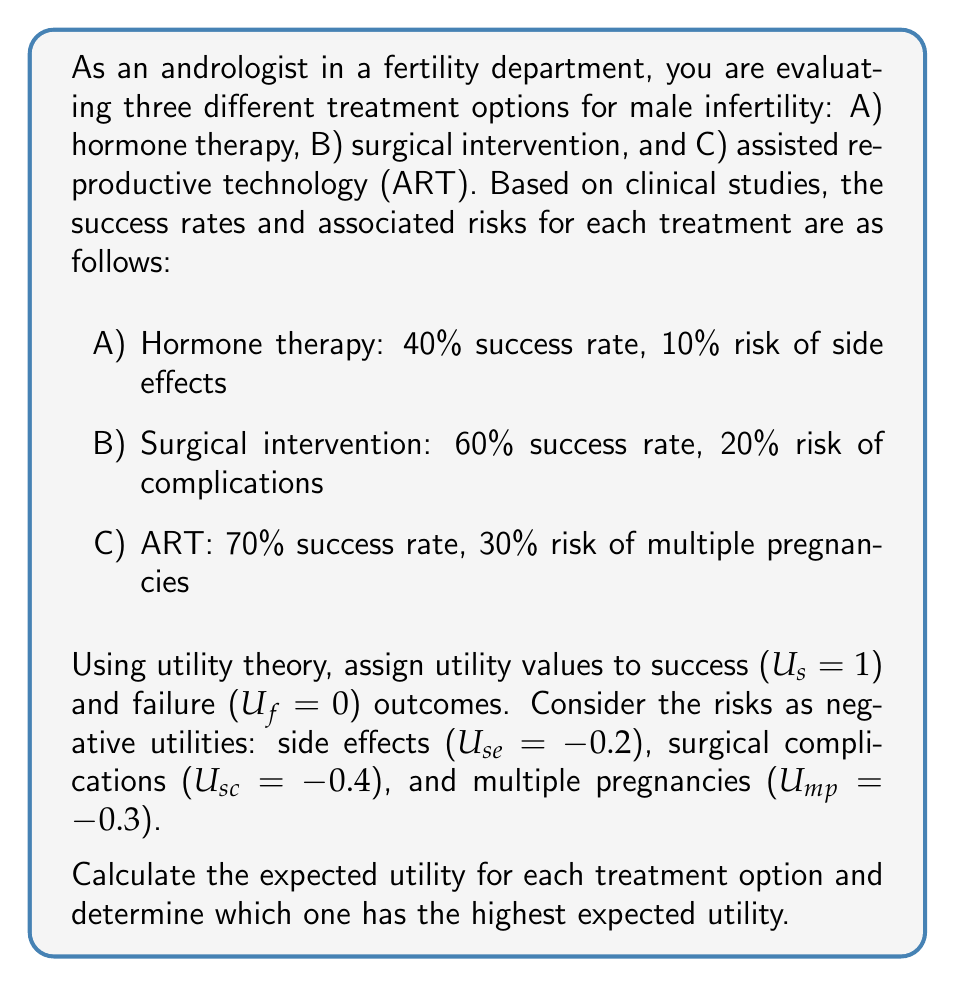Provide a solution to this math problem. To solve this problem using utility theory, we need to calculate the expected utility for each treatment option. The expected utility is the sum of the products of each possible outcome's probability and its associated utility.

Let's calculate the expected utility for each treatment option:

A) Hormone therapy:
Success probability: 0.4
Failure probability: 0.6
Risk of side effects: 0.1

Expected Utility = (Success probability × U_s) + (Failure probability × U_f) + (Risk of side effects × U_se)
$$E(U_A) = (0.4 \times 1) + (0.6 \times 0) + (0.1 \times -0.2)$$
$$E(U_A) = 0.4 - 0.02 = 0.38$$

B) Surgical intervention:
Success probability: 0.6
Failure probability: 0.4
Risk of complications: 0.2

Expected Utility = (Success probability × U_s) + (Failure probability × U_f) + (Risk of complications × U_sc)
$$E(U_B) = (0.6 \times 1) + (0.4 \times 0) + (0.2 \times -0.4)$$
$$E(U_B) = 0.6 - 0.08 = 0.52$$

C) Assisted reproductive technology (ART):
Success probability: 0.7
Failure probability: 0.3
Risk of multiple pregnancies: 0.3

Expected Utility = (Success probability × U_s) + (Failure probability × U_f) + (Risk of multiple pregnancies × U_mp)
$$E(U_C) = (0.7 \times 1) + (0.3 \times 0) + (0.3 \times -0.3)$$
$$E(U_C) = 0.7 - 0.09 = 0.61$$

Now, we can compare the expected utilities of all three treatment options:

E(U_A) = 0.38
E(U_B) = 0.52
E(U_C) = 0.61

The treatment option with the highest expected utility is C) Assisted reproductive technology (ART), with an expected utility of 0.61.
Answer: The treatment option with the highest expected utility is C) Assisted reproductive technology (ART), with an expected utility of 0.61. 